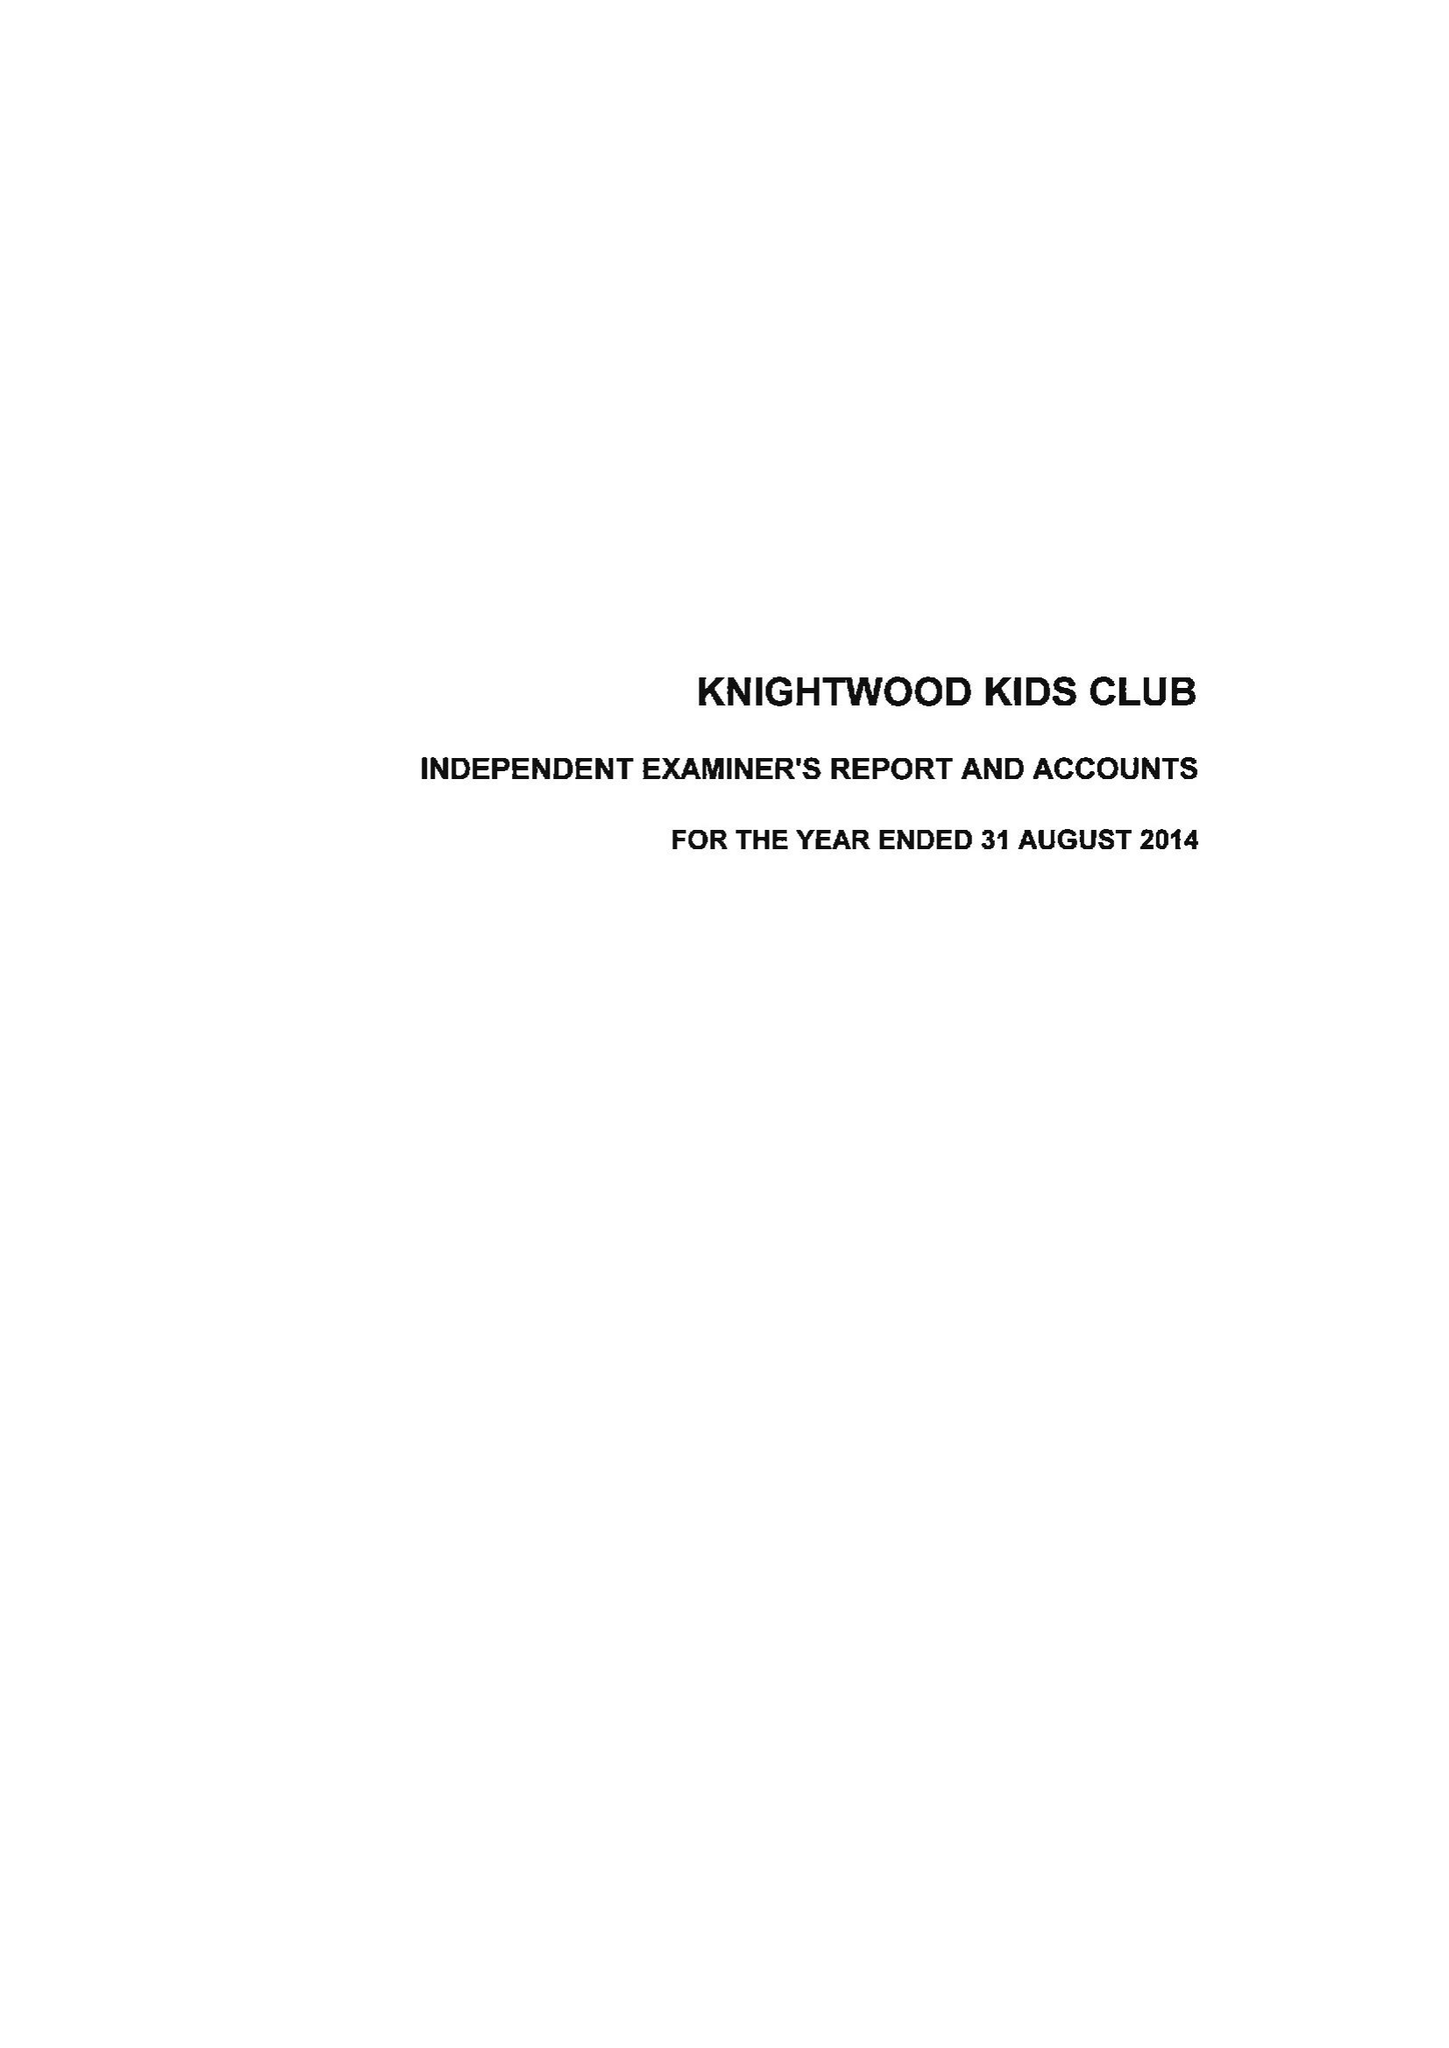What is the value for the report_date?
Answer the question using a single word or phrase. 2014-08-31 